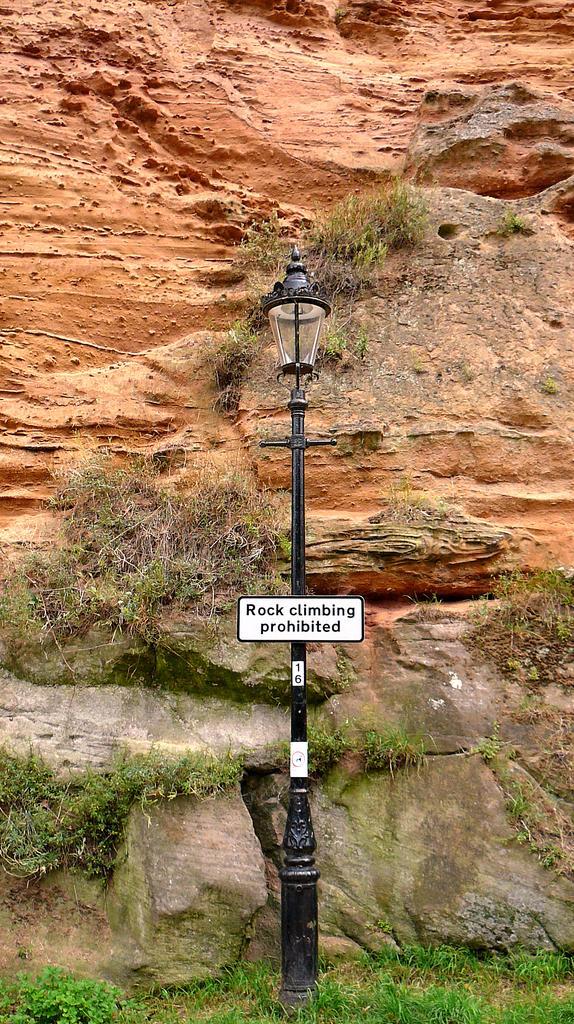In one or two sentences, can you explain what this image depicts? In this image, I can see a board attached to a light pole. In the background, there is a rock and the grass. 